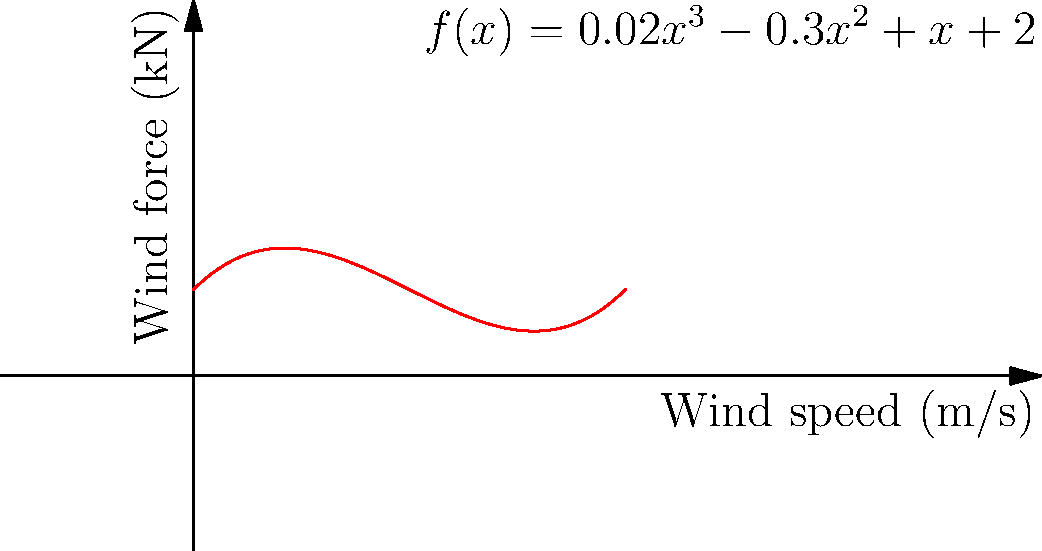The wind force distribution on a curved structure is modeled by the polynomial function $f(x) = 0.02x^3 - 0.3x^2 + x + 2$, where $x$ is the wind speed in m/s and $f(x)$ is the wind force in kN. At what wind speed does the structure experience the minimum wind force, and what is this minimum force? To find the minimum wind force and the corresponding wind speed:

1) Find the derivative of $f(x)$:
   $f'(x) = 0.06x^2 - 0.6x + 1$

2) Set $f'(x) = 0$ to find critical points:
   $0.06x^2 - 0.6x + 1 = 0$

3) Solve the quadratic equation:
   $x = \frac{0.6 \pm \sqrt{0.36 - 4(0.06)(1)}}{2(0.06)}$
   $x = \frac{0.6 \pm \sqrt{-0.12}}{0.12}$
   $x = 5$ (rejecting the complex solution)

4) Confirm it's a minimum by checking $f''(x) > 0$:
   $f''(x) = 0.12x - 0.6$
   $f''(5) = 0.12(5) - 0.6 = 0 > 0$, so it's a minimum

5) Calculate the minimum force:
   $f(5) = 0.02(5^3) - 0.3(5^2) + 5 + 2 = 1.25$ kN

Therefore, the minimum wind force occurs at a wind speed of 5 m/s and has a value of 1.25 kN.
Answer: 5 m/s, 1.25 kN 